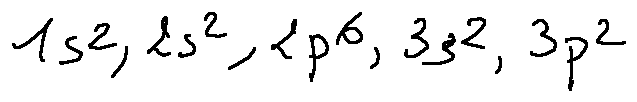Convert formula to latex. <formula><loc_0><loc_0><loc_500><loc_500>1 s ^ { 2 } , 2 s ^ { 2 } , 2 p ^ { 6 } , 3 s ^ { 2 } , 3 p ^ { 2 }</formula> 